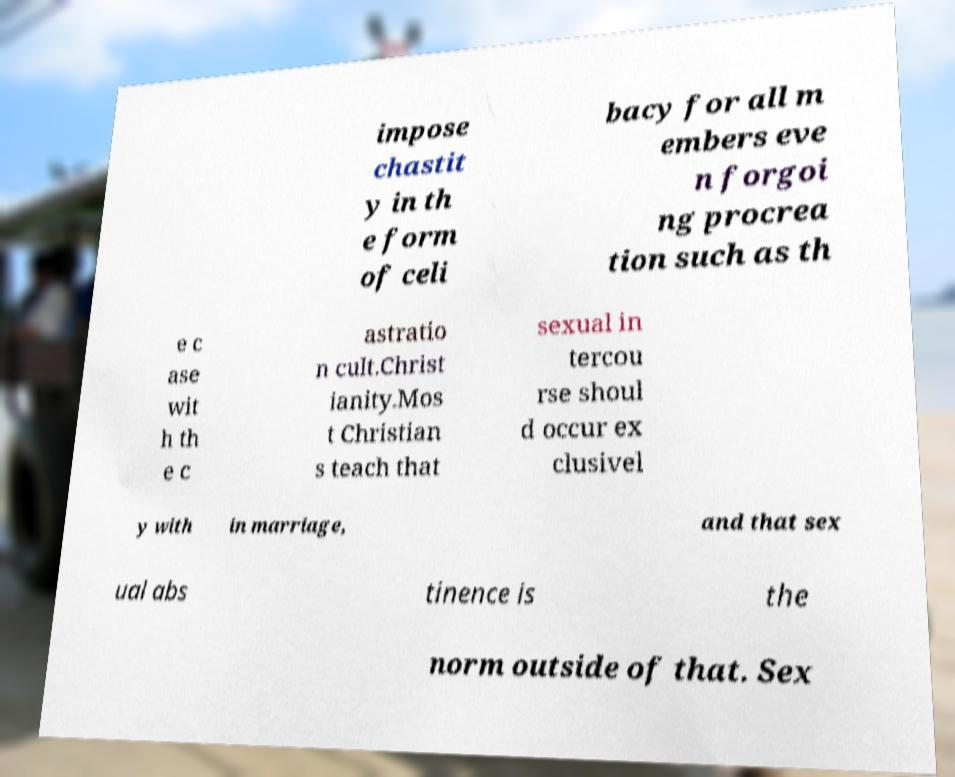Please identify and transcribe the text found in this image. impose chastit y in th e form of celi bacy for all m embers eve n forgoi ng procrea tion such as th e c ase wit h th e c astratio n cult.Christ ianity.Mos t Christian s teach that sexual in tercou rse shoul d occur ex clusivel y with in marriage, and that sex ual abs tinence is the norm outside of that. Sex 